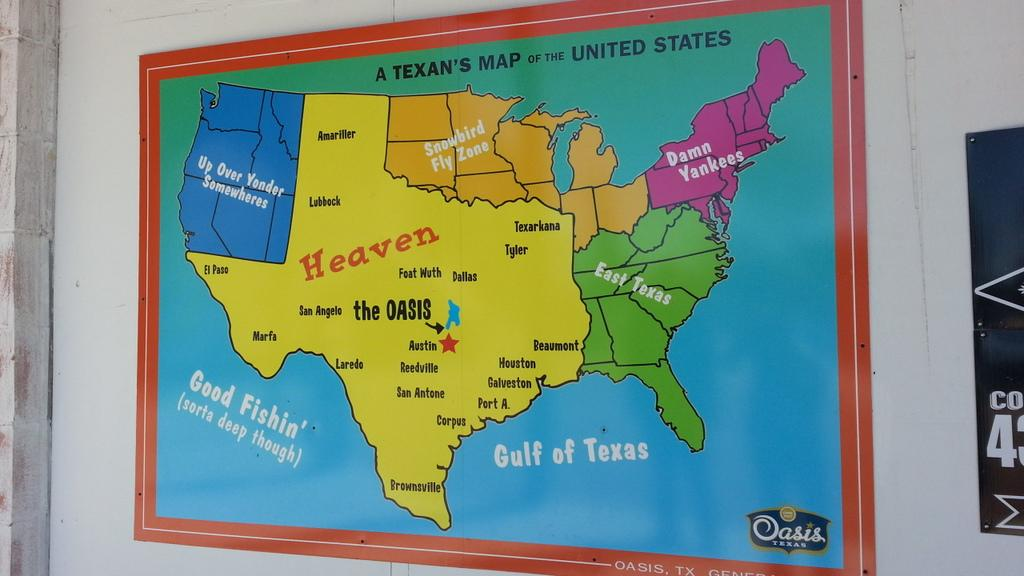<image>
Render a clear and concise summary of the photo. A map is titled A Texan's Map of the United States. 